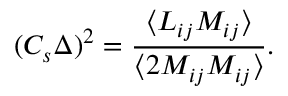<formula> <loc_0><loc_0><loc_500><loc_500>( C _ { s } \Delta ) ^ { 2 } = \frac { \langle L _ { i j } M _ { i j } \rangle } { \langle 2 M _ { i j } M _ { i j } \rangle } .</formula> 